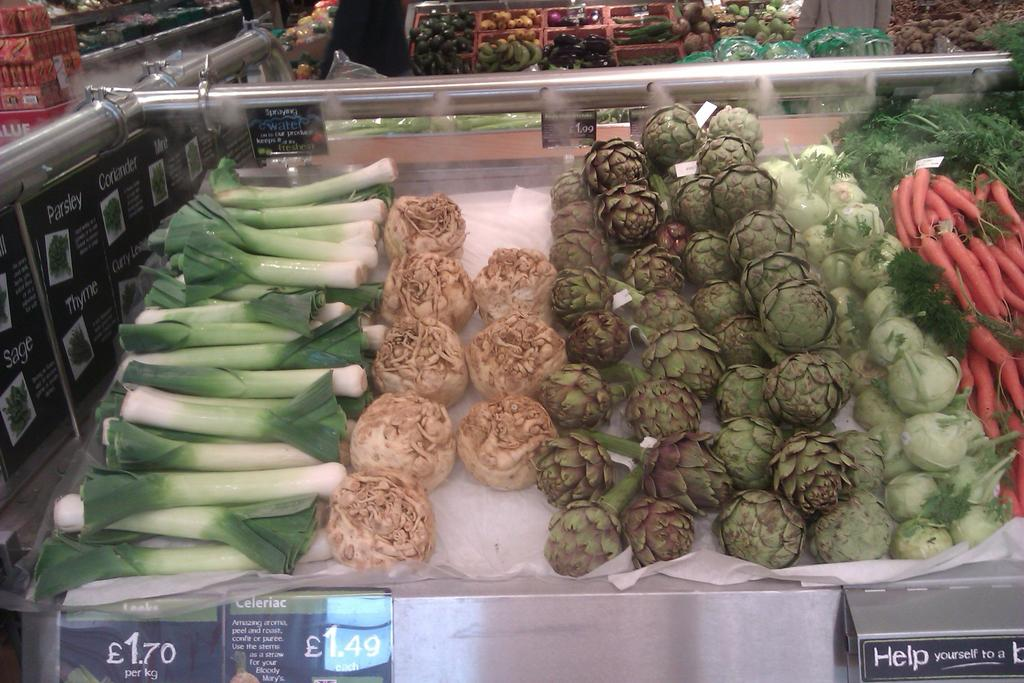What type of food can be seen on the tables and in the baskets in the image? There are vegetables on the tables and in the baskets in the image. What else is present on the tables besides the vegetables? There are boards on the tables. What information is displayed on the boards? There is text and prices on the boards. How does the doll contribute to the wealth of the garden in the image? There is no doll present in the image, and therefore it cannot contribute to the wealth of the garden. 